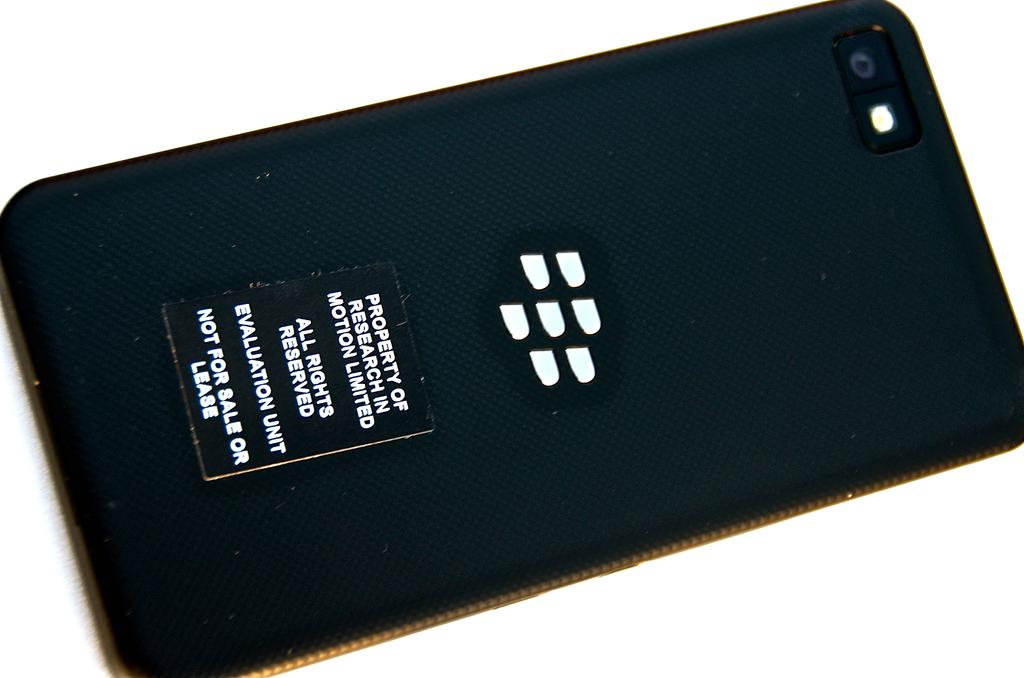<image>
Describe the image concisely. The back of the phone case states it's the property of Research in Motion Limited. 